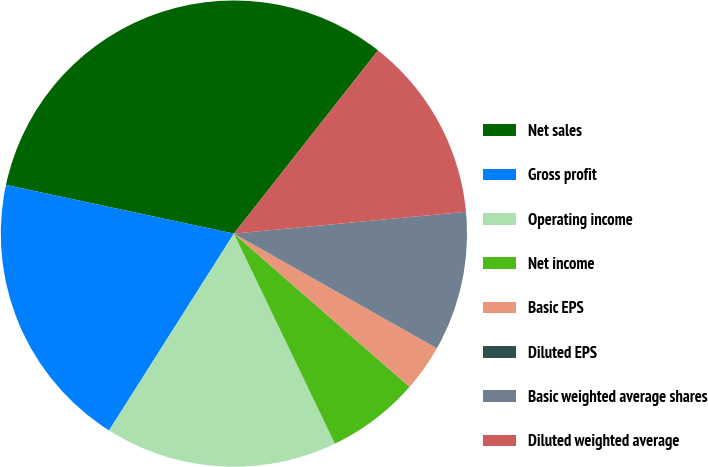Convert chart to OTSL. <chart><loc_0><loc_0><loc_500><loc_500><pie_chart><fcel>Net sales<fcel>Gross profit<fcel>Operating income<fcel>Net income<fcel>Basic EPS<fcel>Diluted EPS<fcel>Basic weighted average shares<fcel>Diluted weighted average<nl><fcel>32.26%<fcel>19.35%<fcel>16.13%<fcel>6.45%<fcel>3.23%<fcel>0.0%<fcel>9.68%<fcel>12.9%<nl></chart> 